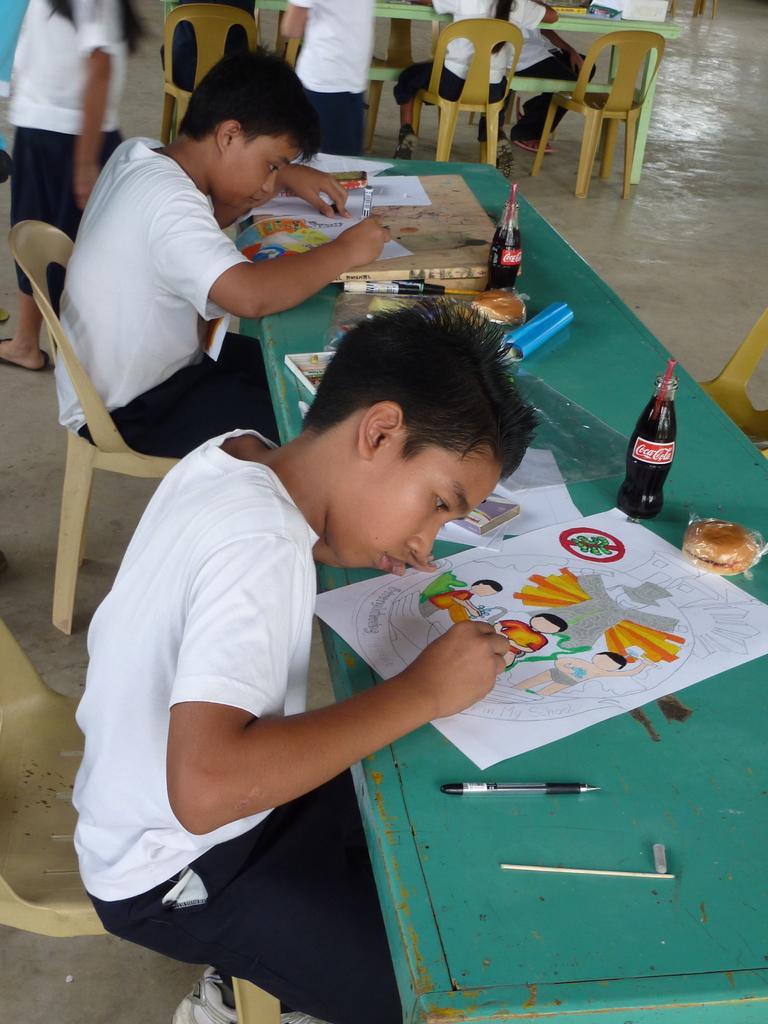Could you give a brief overview of what you see in this image? In this image there are kids sitting on the chair and drawing something on the sheets and on the top of the table there are bottles,burgers,pens. 